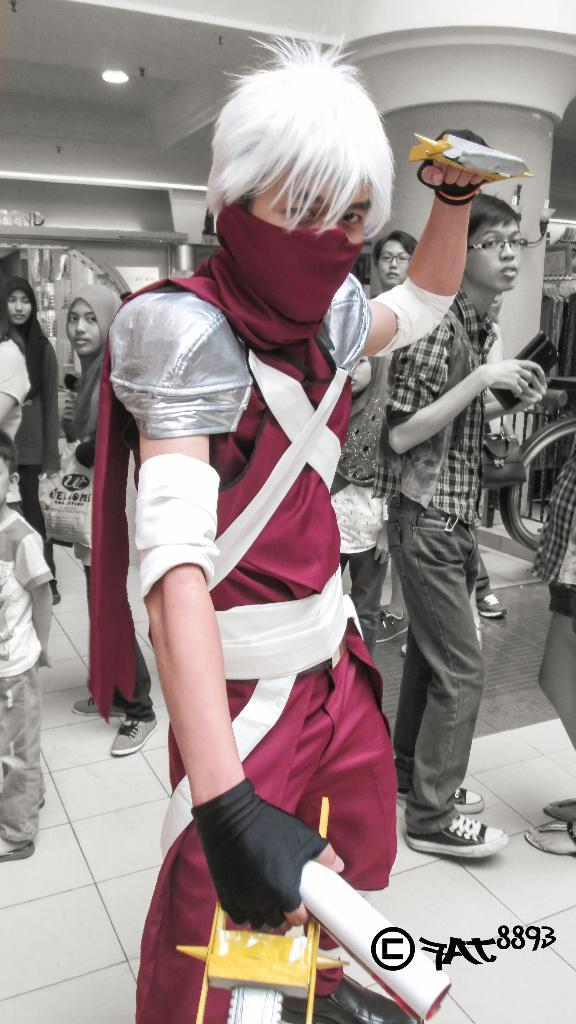What is the person in the image wearing on their face? The person in the image is wearing a mask. How many other persons can be seen in the image? There are other persons standing on the floor in the image. What can be seen at the top of the image? There is a beam and a light visible at the top of the image. What type of dirt can be seen on the floor in the image? There is no dirt visible on the floor in the image. What act is the person wearing a mask performing in the image? The image does not show the person performing any specific act; they are simply standing on the floor. 